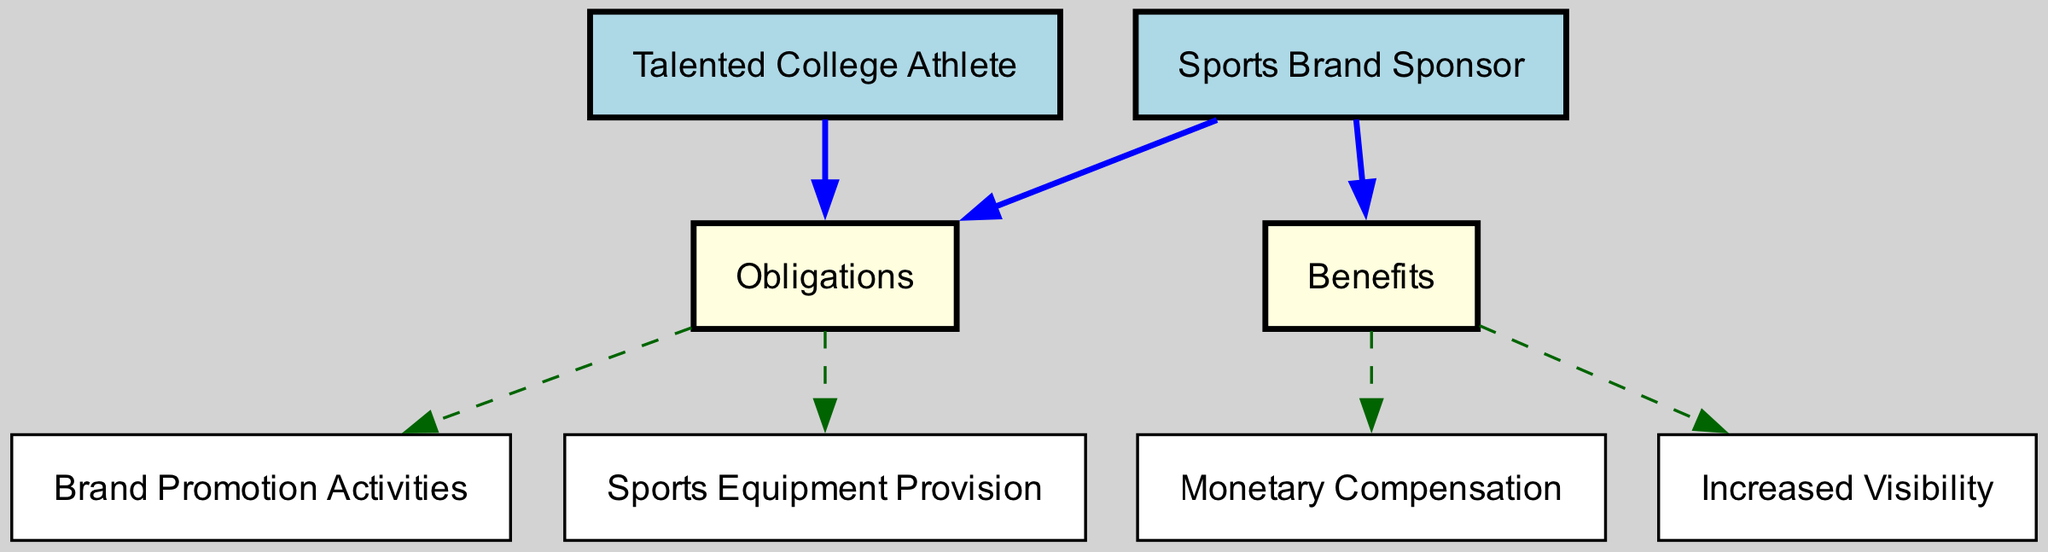What is the total number of nodes in the diagram? The nodes are: Talented College Athlete, Sports Brand Sponsor, Obligations, Benefits, Monetary Compensation, Brand Promotion Activities, Sports Equipment Provision, Increased Visibility. Counting these gives a total of 8 nodes.
Answer: 8 How many edges connect to the "Benefits" node? The edges connecting to the Benefits node are from Obligations and Sponsor, and it connects to Payment and Visibility. This results in a total of 3 edges connected to the Benefits node.
Answer: 3 What is the relationship between "Athlete" and "Obligations"? The relationship is a direct connection where the Athlete is obliged to fulfill certain Obligations, represented by an edge leading from Athlete to Obligations.
Answer: Obliged Which node provides "Monetary Compensation"? The Benefits node ultimately leads to Monetary Compensation, indicating it is one of the rewards for fulfilling the obligations outlined in the sponsorship agreement.
Answer: Benefits What color represents "Obligations" in the diagram? Obligations are represented by a light yellow color according to the node color coding in the diagram.
Answer: Light yellow How many total edges does the diagram have? There are 7 edges present in this directed graph since each directed relationship between nodes counts as an edge.
Answer: 7 What are the obligations of the athlete based on the diagram? The obligations of the athlete, connected from the Obligations node, include Brand Promotion Activities and Sports Equipment Provision.
Answer: Brand Promotion Activities, Sports Equipment Provision What node connects both the athlete and sponsor to their responsibilities? The Obligations node connects both the Athlete and Sponsor, indicating it is a common point for their responsibilities in the sponsorship agreement.
Answer: Obligations What is the outcome of fulfilling obligations in terms of benefits? Fulfilling the obligations leads to acquiring Benefits such as Monetary Compensation and Increased Visibility, indicating a direct correlation between duties and rewards.
Answer: Benefits 